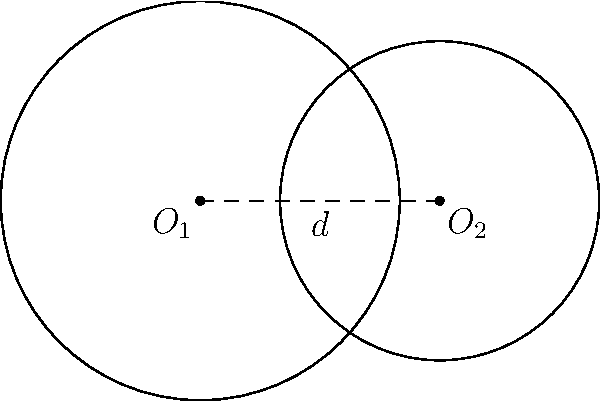In a bioinformatics study, two circular DNA fragments are represented by overlapping circles with radii $r_1 = 2.5$ units and $r_2 = 2$ units, respectively. The centers of these circles are separated by a distance $d = 3$ units. Calculate the area of the overlapping region between these two circular DNA fragments. Round your answer to three decimal places. To solve this problem, we'll use the formula for the area of intersection between two circles:

1) First, calculate the angles $\theta_1$ and $\theta_2$:
   $$\cos(\frac{\theta_1}{2}) = \frac{d^2 + r_1^2 - r_2^2}{2dr_1}$$
   $$\cos(\frac{\theta_2}{2}) = \frac{d^2 + r_2^2 - r_1^2}{2dr_2}$$

2) Substitute the values:
   $$\cos(\frac{\theta_1}{2}) = \frac{3^2 + 2.5^2 - 2^2}{2 * 3 * 2.5} = 0.7$$
   $$\cos(\frac{\theta_2}{2}) = \frac{3^2 + 2^2 - 2.5^2}{2 * 3 * 2} = 0.5833$$

3) Calculate $\theta_1$ and $\theta_2$:
   $$\theta_1 = 2 * \arccos(0.7) = 1.5904 \text{ radians}$$
   $$\theta_2 = 2 * \arccos(0.5833) = 1.8385 \text{ radians}$$

4) The area of intersection is given by:
   $$A = \frac{1}{2}r_1^2(\theta_1 - \sin(\theta_1)) + \frac{1}{2}r_2^2(\theta_2 - \sin(\theta_2))$$

5) Substitute the values:
   $$A = \frac{1}{2}(2.5)^2(1.5904 - \sin(1.5904)) + \frac{1}{2}(2)^2(1.8385 - \sin(1.8385))$$

6) Calculate:
   $$A = 3.1250(1.5904 - 0.9996) + 2(1.8385 - 0.9679)$$
   $$A = 1.8463 + 1.7412 = 3.5875$$

7) Round to three decimal places:
   $$A \approx 3.588 \text{ square units}$$
Answer: 3.588 square units 